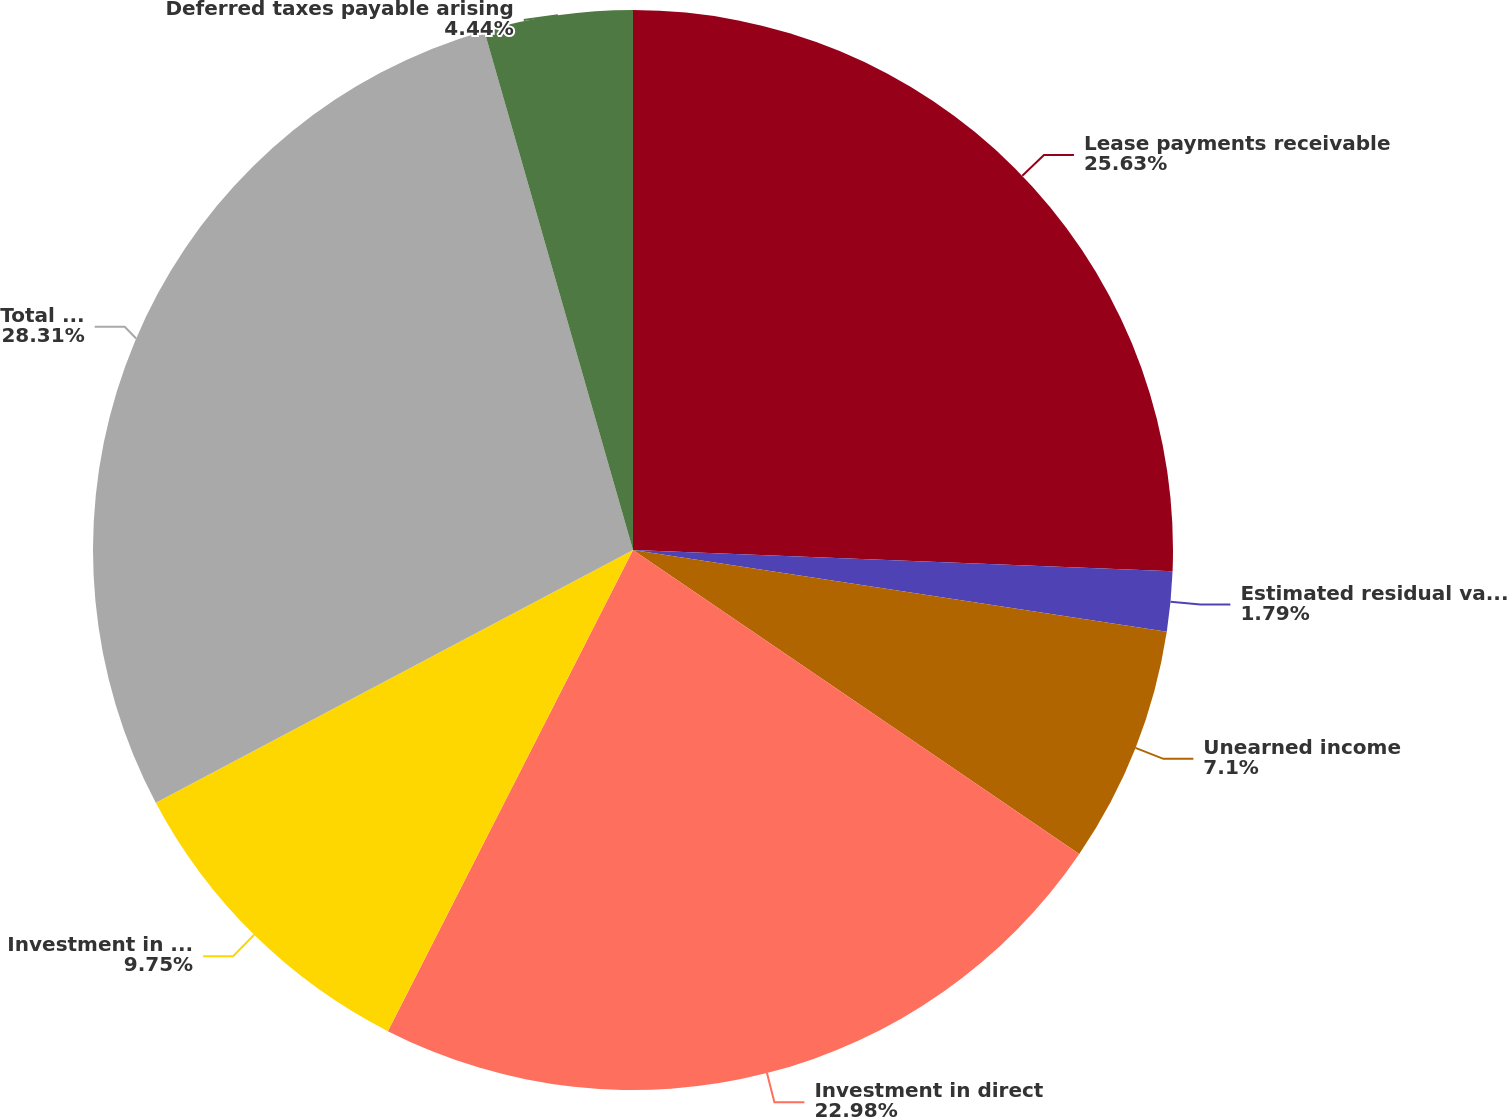Convert chart to OTSL. <chart><loc_0><loc_0><loc_500><loc_500><pie_chart><fcel>Lease payments receivable<fcel>Estimated residual value of<fcel>Unearned income<fcel>Investment in direct<fcel>Investment in leveraged leases<fcel>Total investment in leases<fcel>Deferred taxes payable arising<nl><fcel>25.63%<fcel>1.79%<fcel>7.1%<fcel>22.98%<fcel>9.75%<fcel>28.31%<fcel>4.44%<nl></chart> 